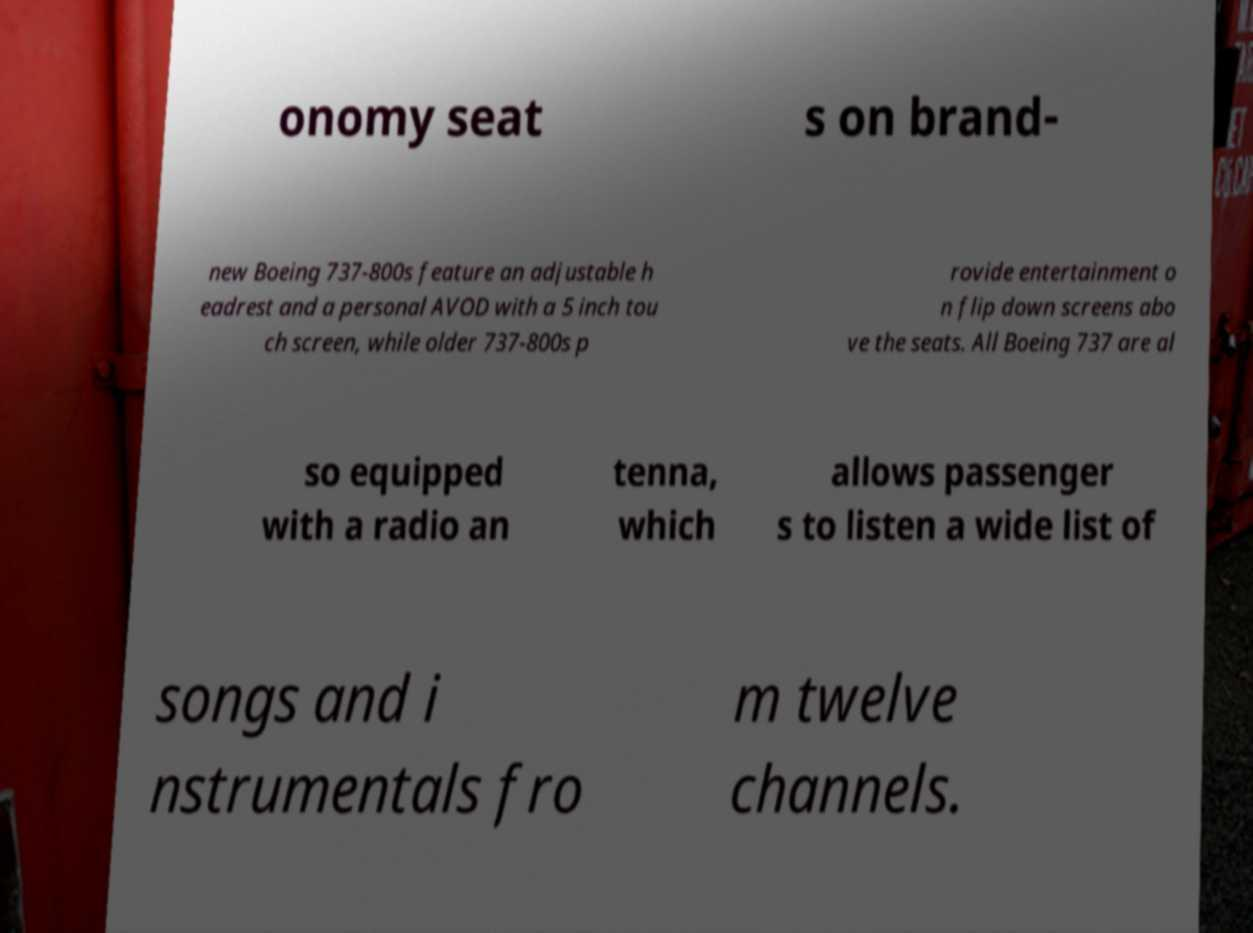What messages or text are displayed in this image? I need them in a readable, typed format. onomy seat s on brand- new Boeing 737-800s feature an adjustable h eadrest and a personal AVOD with a 5 inch tou ch screen, while older 737-800s p rovide entertainment o n flip down screens abo ve the seats. All Boeing 737 are al so equipped with a radio an tenna, which allows passenger s to listen a wide list of songs and i nstrumentals fro m twelve channels. 